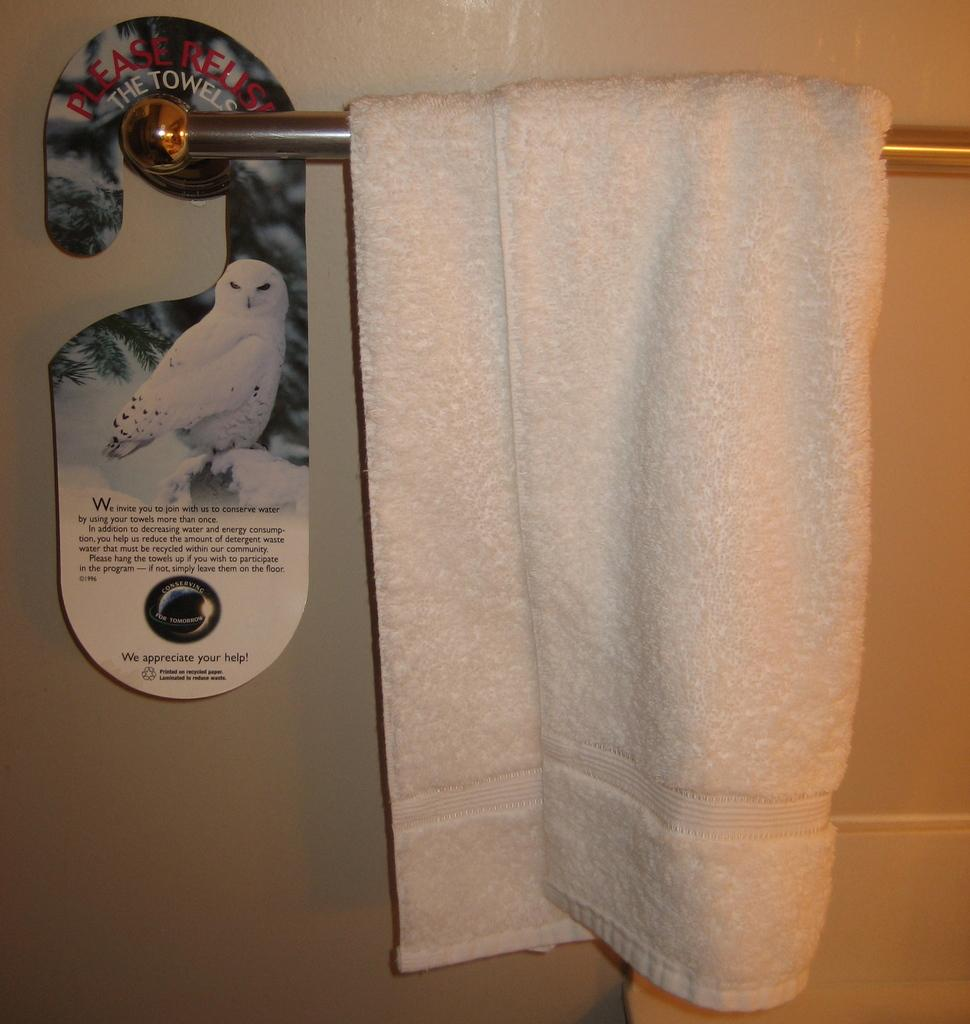What is hanging on a rod in the image? There is a towel hanging on a rod in the image. What can be seen on the left side of the image? There is a board with text on the left side of the image. What is visible in the background of the image? There is a wall visible in the background of the image. What color is the paint on the mouth of the person in the image? There is no person or mouth present in the image; it features a towel hanging on a rod and a board with text. What type of building is visible in the background of the image? There is no building visible in the background of the image; it features a wall. 